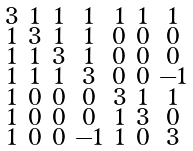<formula> <loc_0><loc_0><loc_500><loc_500>\begin{smallmatrix} 3 & 1 & 1 & 1 & 1 & 1 & 1 \\ 1 & 3 & 1 & 1 & 0 & 0 & 0 \\ 1 & 1 & 3 & 1 & 0 & 0 & 0 \\ 1 & 1 & 1 & 3 & 0 & 0 & - 1 \\ 1 & 0 & 0 & 0 & 3 & 1 & 1 \\ 1 & 0 & 0 & 0 & 1 & 3 & 0 \\ 1 & 0 & 0 & - 1 & 1 & 0 & 3 \end{smallmatrix}</formula> 